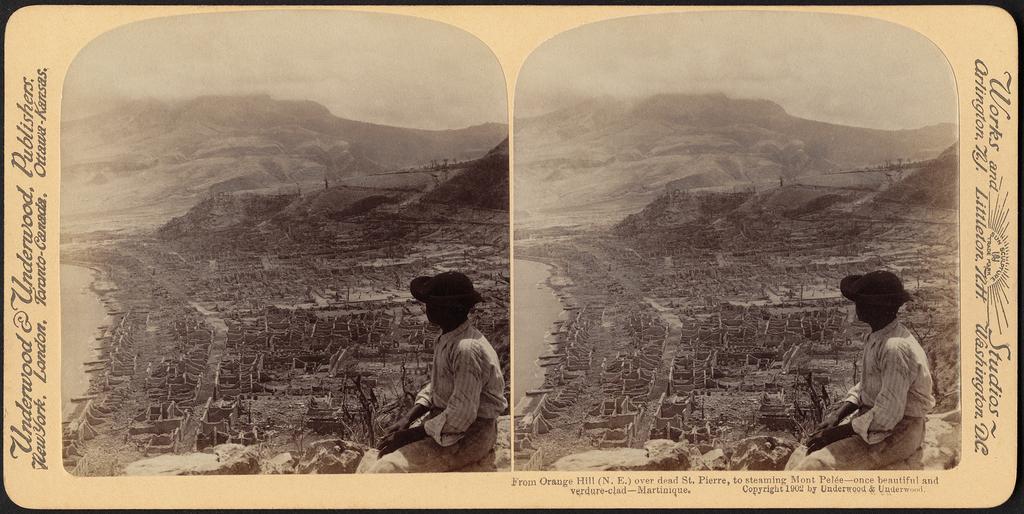Describe this image in one or two sentences. This picture is a collage of two images. In these two images I can observe a person sitting on the rock. I can observe a river on the left side of the two images. In the background there are hills and sky. This is a black and white picture. I can observe some text on either sides of the picture. 